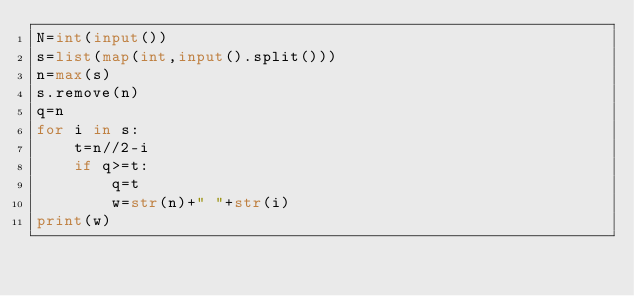Convert code to text. <code><loc_0><loc_0><loc_500><loc_500><_Python_>N=int(input())
s=list(map(int,input().split()))
n=max(s)
s.remove(n)
q=n
for i in s:
    t=n//2-i
    if q>=t:
        q=t
        w=str(n)+" "+str(i)
print(w)        
    </code> 